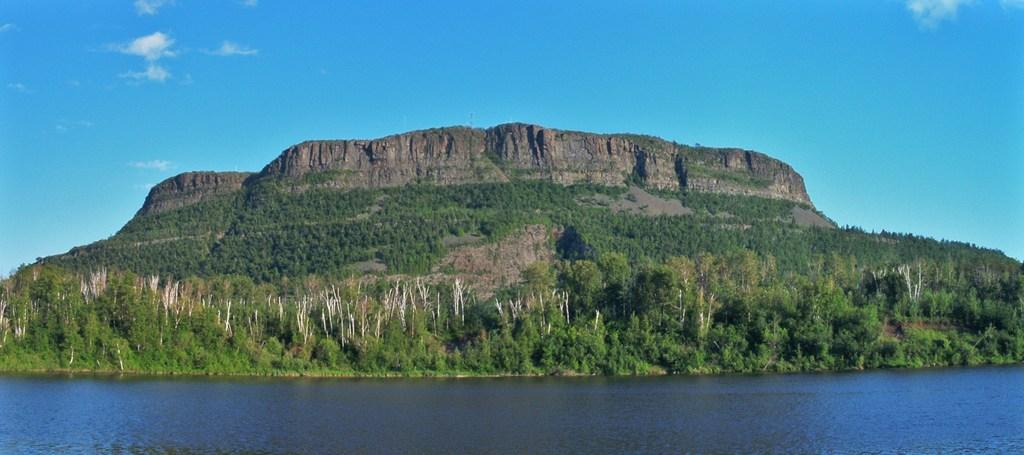What type of natural feature is present in the image? There is a river in the image. What other natural elements can be seen in the image? There are plants, trees, and a hill visible in the image. What is visible in the background of the image? The sky is visible in the background of the image. What can be observed in the sky? There are clouds in the sky. What color is the daughter's dress in the image? There is no daughter present in the image. How does the brush affect the river in the image? There is no brush present in the image, so it cannot affect the river. 